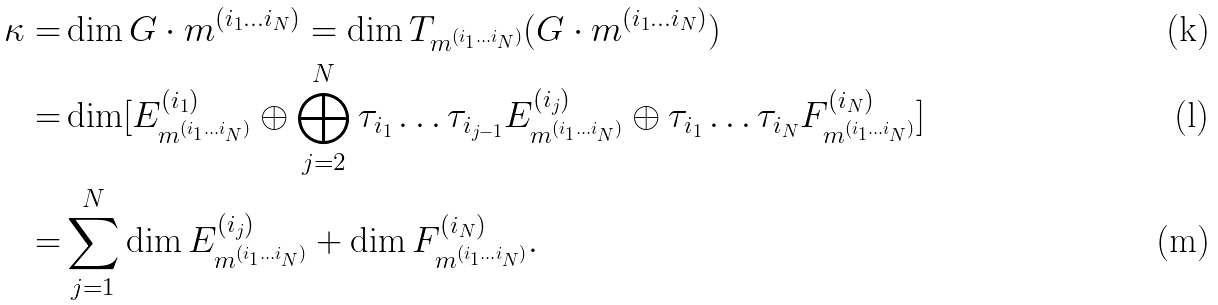<formula> <loc_0><loc_0><loc_500><loc_500>\kappa = & \dim G \cdot m ^ { ( i _ { 1 } \dots i _ { N } ) } = \dim T _ { m ^ { ( i _ { 1 } \dots i _ { N } ) } } ( G \cdot m ^ { ( i _ { 1 } \dots i _ { N } ) } ) \\ = & \dim [ E ^ { ( i _ { 1 } ) } _ { m ^ { ( i _ { 1 } \dots i _ { N } ) } } \oplus \bigoplus _ { j = 2 } ^ { N } \tau _ { i _ { 1 } } \dots \tau _ { i _ { j - 1 } } E ^ { ( i _ { j } ) } _ { m ^ { ( i _ { 1 } \dots i _ { N } ) } } \oplus \tau _ { i _ { 1 } } \dots \tau _ { i _ { N } } F ^ { ( i _ { N } ) } _ { m ^ { ( i _ { 1 } \dots i _ { N } ) } } ] \\ = & \sum _ { j = 1 } ^ { N } \dim E ^ { ( i _ { j } ) } _ { m ^ { ( i _ { 1 } \dots i _ { N } ) } } + \dim F ^ { ( i _ { N } ) } _ { m ^ { ( i _ { 1 } \dots i _ { N } ) } } .</formula> 